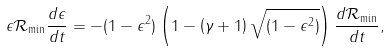<formula> <loc_0><loc_0><loc_500><loc_500>\epsilon \mathcal { R } _ { \min } \frac { d \epsilon } { d t } = - ( 1 - \epsilon ^ { 2 } ) \left ( 1 - \left ( \gamma + 1 \right ) \sqrt { ( 1 - \epsilon ^ { 2 } ) } \right ) \frac { d \mathcal { R } _ { \min } } { d t } ,</formula> 